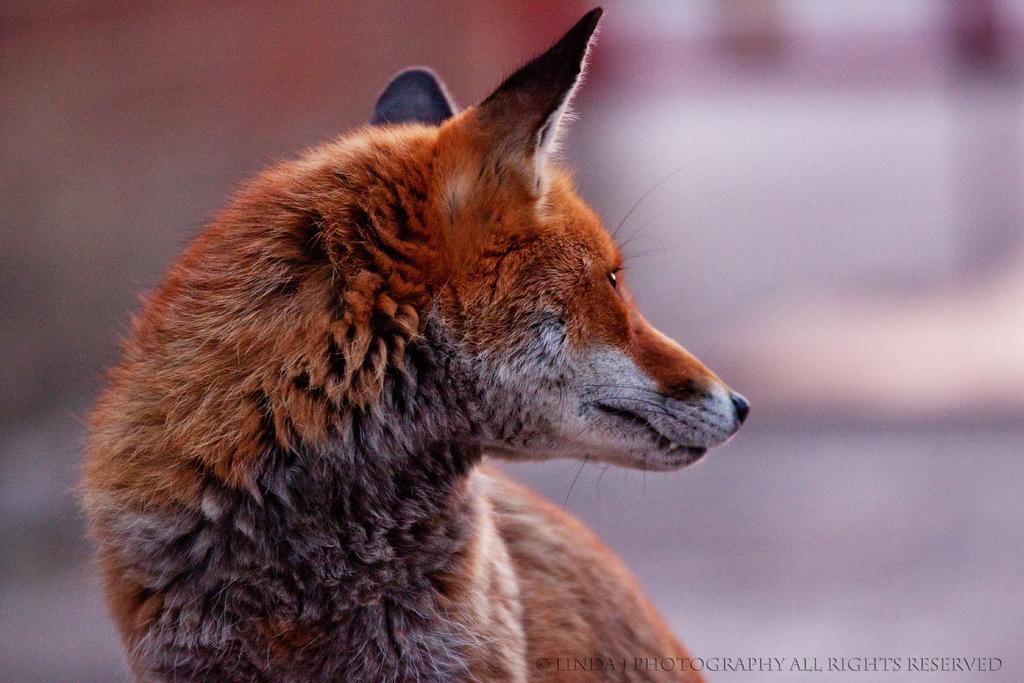Please provide a concise description of this image. In the picture I can see a red fox and there is something written in the right bottom corner. 